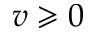<formula> <loc_0><loc_0><loc_500><loc_500>v \geqslant 0</formula> 